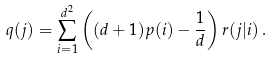Convert formula to latex. <formula><loc_0><loc_0><loc_500><loc_500>q ( j ) = \sum _ { i = 1 } ^ { d ^ { 2 } } \left ( ( d + 1 ) p ( i ) - \frac { 1 } { d } \right ) r ( j | i ) \, .</formula> 